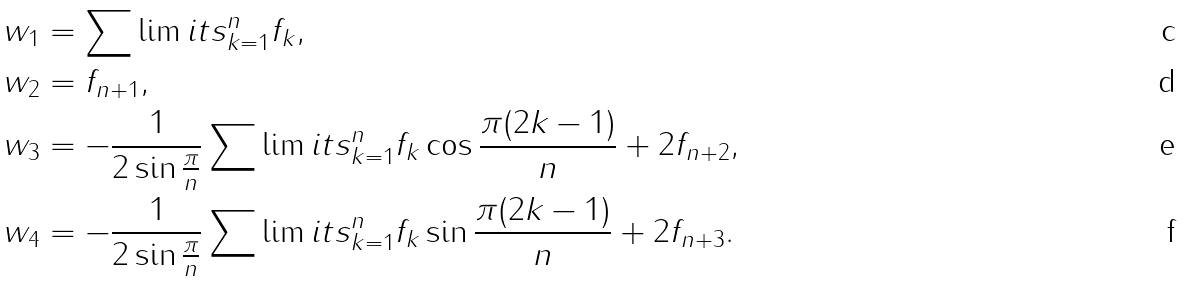Convert formula to latex. <formula><loc_0><loc_0><loc_500><loc_500>& w _ { 1 } = \sum \lim i t s _ { k = 1 } ^ { n } f _ { k } , \\ & w _ { 2 } = f _ { n + 1 } , \\ & w _ { 3 } = - \frac { 1 } { 2 \sin \frac { \pi } { n } } \sum \lim i t s _ { k = 1 } ^ { n } f _ { k } \cos \frac { \pi ( 2 k - 1 ) } { n } + 2 f _ { n + 2 } , \\ & w _ { 4 } = - \frac { 1 } { 2 \sin \frac { \pi } { n } } \sum \lim i t s _ { k = 1 } ^ { n } f _ { k } \sin \frac { \pi ( 2 k - 1 ) } { n } + 2 f _ { n + 3 } .</formula> 